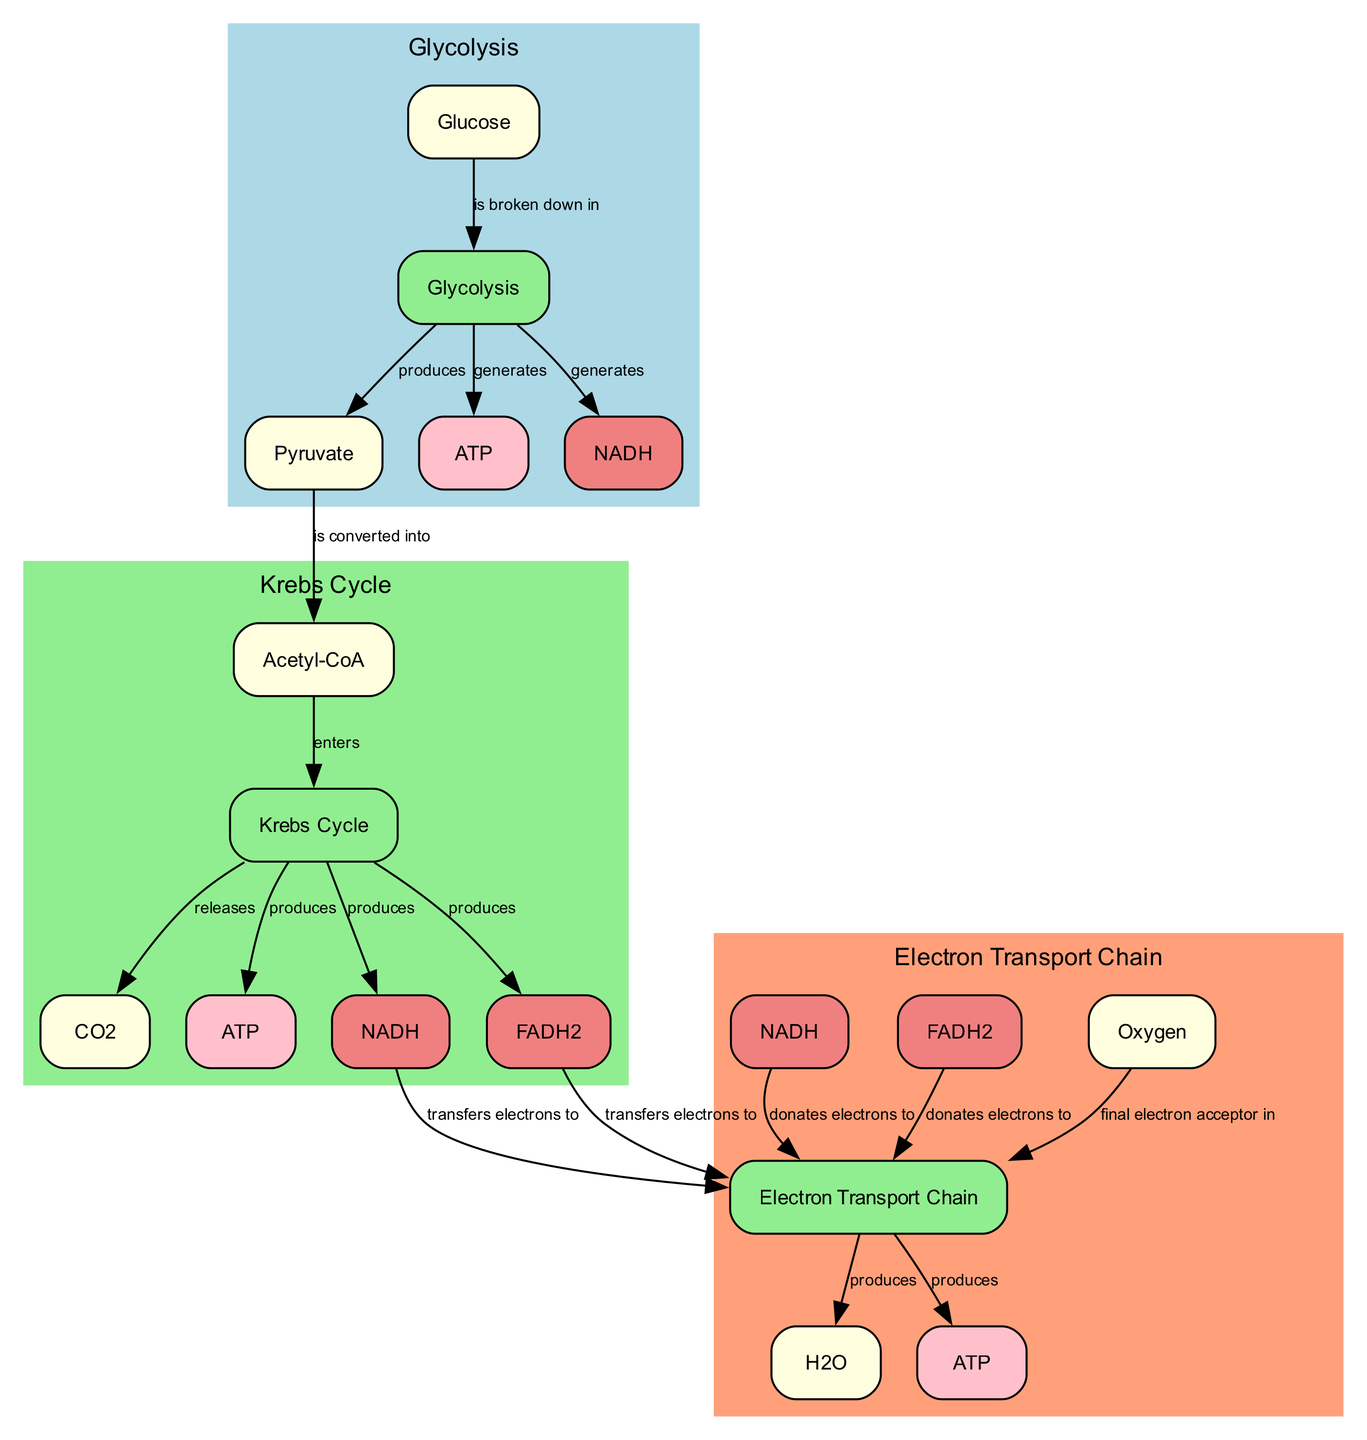What is the starting substrate for glycolysis? The diagram indicates that glucose is the starting substrate for glycolysis, as indicated by the edge linking glucose to the glycolysis process.
Answer: Glucose How many products are produced by glycolysis? Observing the outputs of glycolysis in the diagram, we see it produces three products: pyruvate, ATP, and NADH.
Answer: Three What enters the Krebs cycle? From the diagram, it shows that Acetyl-CoA enters the Krebs cycle, as indicated by the directed edge connecting acetyl_coa to krebs_cycle.
Answer: Acetyl-CoA What is produced during the Krebs cycle that is also part of cellular respiration? ATP is one of the products generated in the Krebs cycle, and it is a key energy currency used in cellular respiration; this is evident from the label on the ATP node linked to the Krebs cycle.
Answer: ATP Which molecule acts as the final electron acceptor in the electron transport chain? The diagram clearly indicates that Oxygen is the final electron acceptor in the electron transport chain, represented by the edge connecting o2_et to the electron_transport_chain.
Answer: Oxygen What is produced as a by-product of the electron transport chain? Examining the outputs from the electron transport chain, water is produced as a by-product, as indicated by the edge leading from the electron_transport_chain to h2o_et.
Answer: Water How many electron carriers are produced in the Krebs cycle? The diagram shows both NADH and FADH2 as products of the Krebs cycle, indicating two different electron carriers generated in this process.
Answer: Two What is the relationship between NADH from glycolysis and the electron transport chain? The diagram specifies that NADH from glycolysis transfers electrons to the electron transport chain, which is denoted by the edge connecting nadh_glycolysis to electron_transport_chain.
Answer: Transfers electrons What energy currency is primarily produced by the electron transport chain? The diagram indicates that the electron transport chain produces a large amount of ATP, clearly shown by the label at the ATP node connected to the electron_transport_chain.
Answer: ATP 